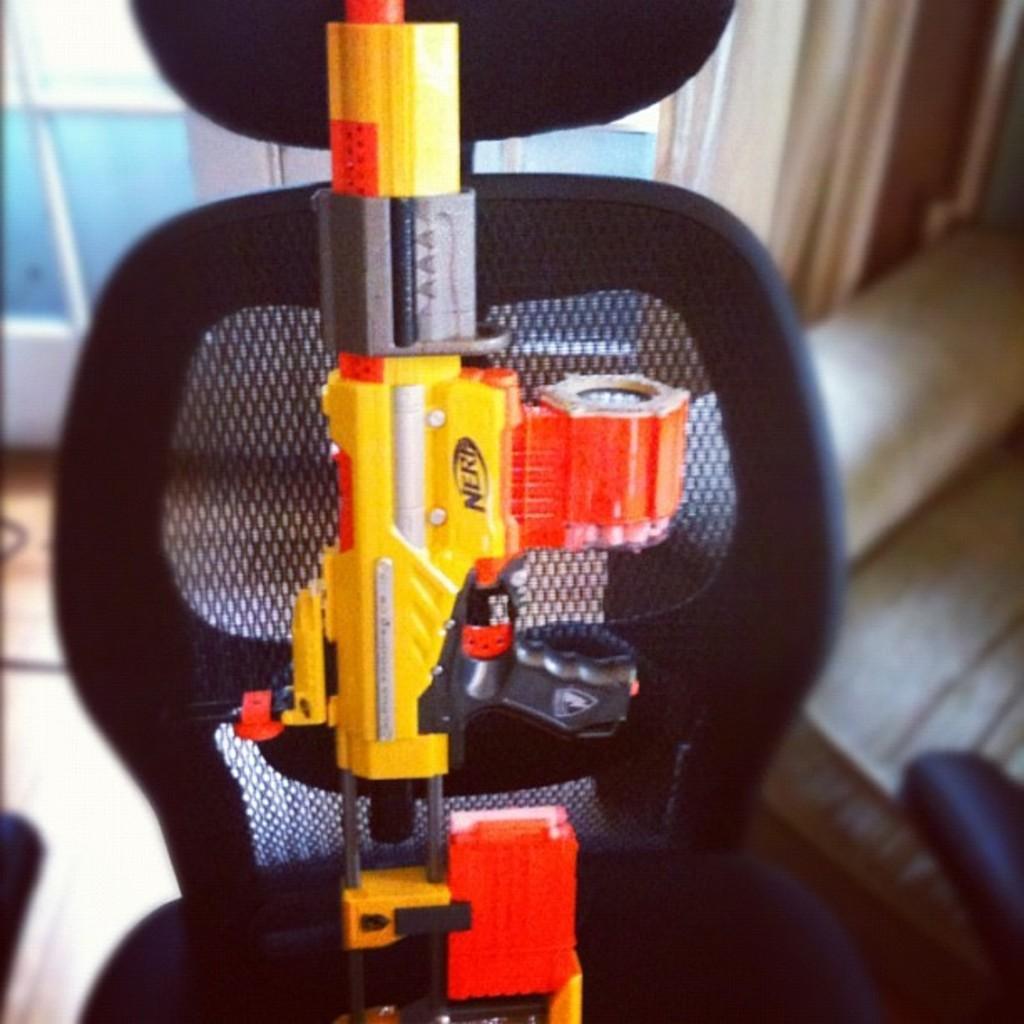Please provide a concise description of this image. In this image, we can see a gun on the black color chair and there is a blur background. 